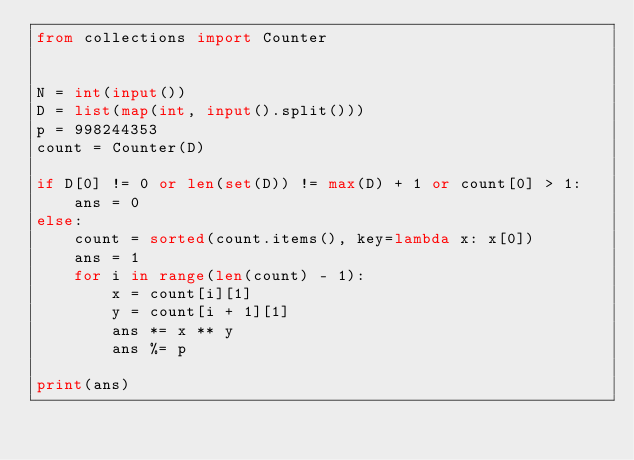Convert code to text. <code><loc_0><loc_0><loc_500><loc_500><_Python_>from collections import Counter


N = int(input())
D = list(map(int, input().split()))
p = 998244353
count = Counter(D)

if D[0] != 0 or len(set(D)) != max(D) + 1 or count[0] > 1:
    ans = 0
else:
    count = sorted(count.items(), key=lambda x: x[0])
    ans = 1
    for i in range(len(count) - 1):
        x = count[i][1]
        y = count[i + 1][1]
        ans *= x ** y
        ans %= p

print(ans)</code> 